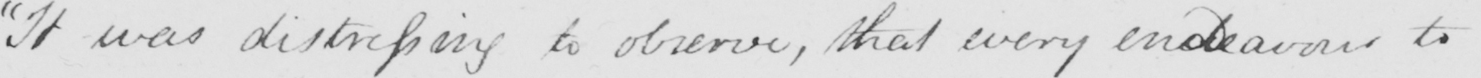What is written in this line of handwriting? "It was distressing to observe that every endeavour to 